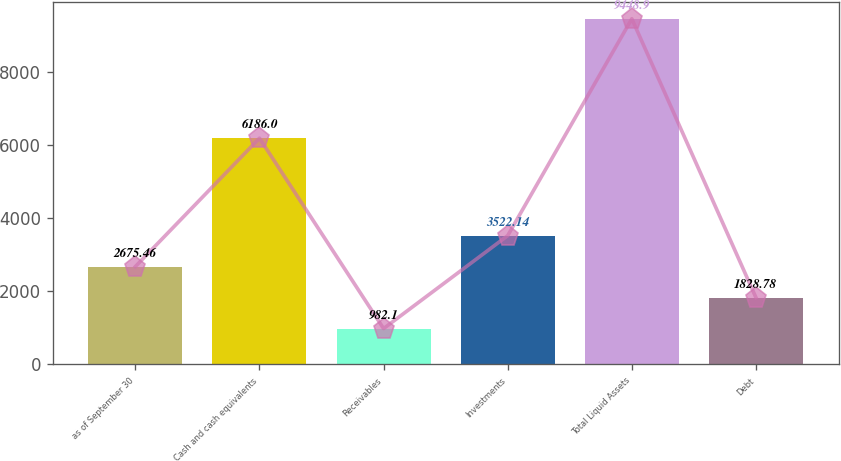Convert chart. <chart><loc_0><loc_0><loc_500><loc_500><bar_chart><fcel>as of September 30<fcel>Cash and cash equivalents<fcel>Receivables<fcel>Investments<fcel>Total Liquid Assets<fcel>Debt<nl><fcel>2675.46<fcel>6186<fcel>982.1<fcel>3522.14<fcel>9448.9<fcel>1828.78<nl></chart> 